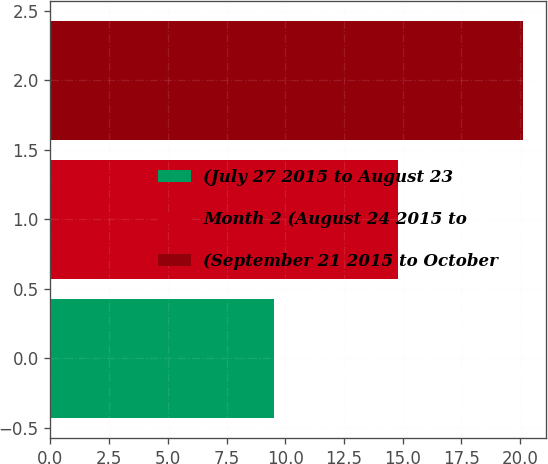Convert chart. <chart><loc_0><loc_0><loc_500><loc_500><bar_chart><fcel>(July 27 2015 to August 23<fcel>Month 2 (August 24 2015 to<fcel>(September 21 2015 to October<nl><fcel>9.5<fcel>14.8<fcel>20.1<nl></chart> 